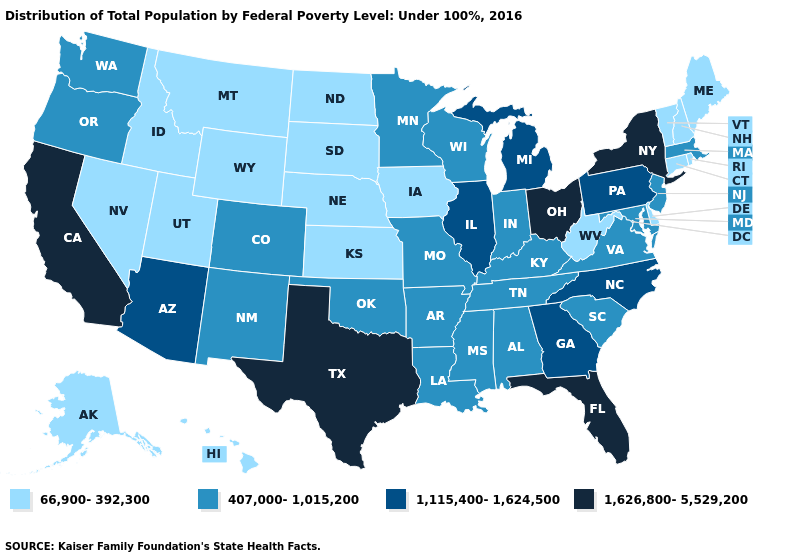What is the highest value in the USA?
Short answer required. 1,626,800-5,529,200. What is the value of Arkansas?
Quick response, please. 407,000-1,015,200. What is the highest value in states that border South Dakota?
Quick response, please. 407,000-1,015,200. Name the states that have a value in the range 66,900-392,300?
Short answer required. Alaska, Connecticut, Delaware, Hawaii, Idaho, Iowa, Kansas, Maine, Montana, Nebraska, Nevada, New Hampshire, North Dakota, Rhode Island, South Dakota, Utah, Vermont, West Virginia, Wyoming. Which states have the highest value in the USA?
Write a very short answer. California, Florida, New York, Ohio, Texas. Does Wisconsin have the highest value in the MidWest?
Concise answer only. No. Among the states that border Mississippi , which have the highest value?
Write a very short answer. Alabama, Arkansas, Louisiana, Tennessee. Which states have the lowest value in the USA?
Keep it brief. Alaska, Connecticut, Delaware, Hawaii, Idaho, Iowa, Kansas, Maine, Montana, Nebraska, Nevada, New Hampshire, North Dakota, Rhode Island, South Dakota, Utah, Vermont, West Virginia, Wyoming. Which states have the lowest value in the USA?
Concise answer only. Alaska, Connecticut, Delaware, Hawaii, Idaho, Iowa, Kansas, Maine, Montana, Nebraska, Nevada, New Hampshire, North Dakota, Rhode Island, South Dakota, Utah, Vermont, West Virginia, Wyoming. Does Florida have the highest value in the USA?
Give a very brief answer. Yes. Does the first symbol in the legend represent the smallest category?
Quick response, please. Yes. Does Wyoming have the same value as Kansas?
Write a very short answer. Yes. Does Nevada have the highest value in the USA?
Short answer required. No. Name the states that have a value in the range 66,900-392,300?
Quick response, please. Alaska, Connecticut, Delaware, Hawaii, Idaho, Iowa, Kansas, Maine, Montana, Nebraska, Nevada, New Hampshire, North Dakota, Rhode Island, South Dakota, Utah, Vermont, West Virginia, Wyoming. Which states hav the highest value in the MidWest?
Answer briefly. Ohio. 